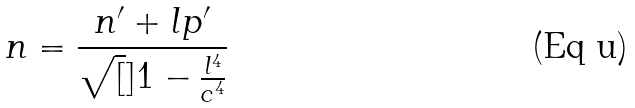<formula> <loc_0><loc_0><loc_500><loc_500>n = \frac { n ^ { \prime } + l p ^ { \prime } } { \sqrt { [ } ] { 1 - \frac { l ^ { 4 } } { c ^ { 4 } } } }</formula> 